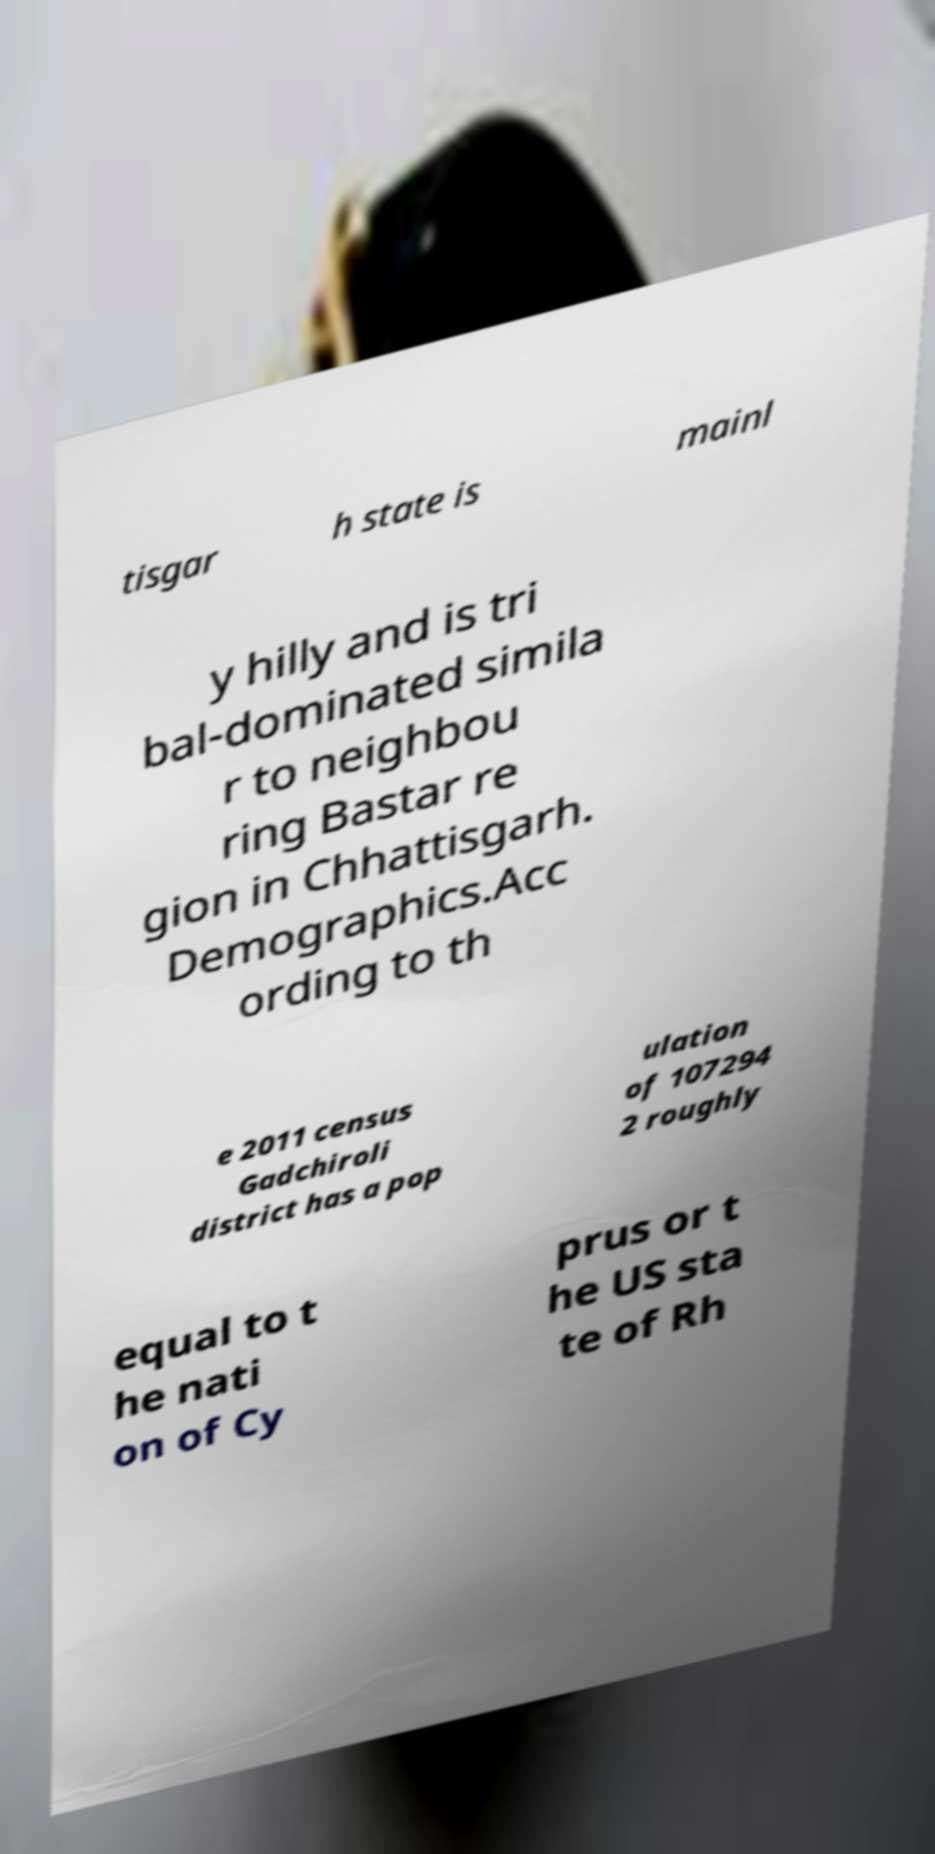Can you read and provide the text displayed in the image?This photo seems to have some interesting text. Can you extract and type it out for me? tisgar h state is mainl y hilly and is tri bal-dominated simila r to neighbou ring Bastar re gion in Chhattisgarh. Demographics.Acc ording to th e 2011 census Gadchiroli district has a pop ulation of 107294 2 roughly equal to t he nati on of Cy prus or t he US sta te of Rh 